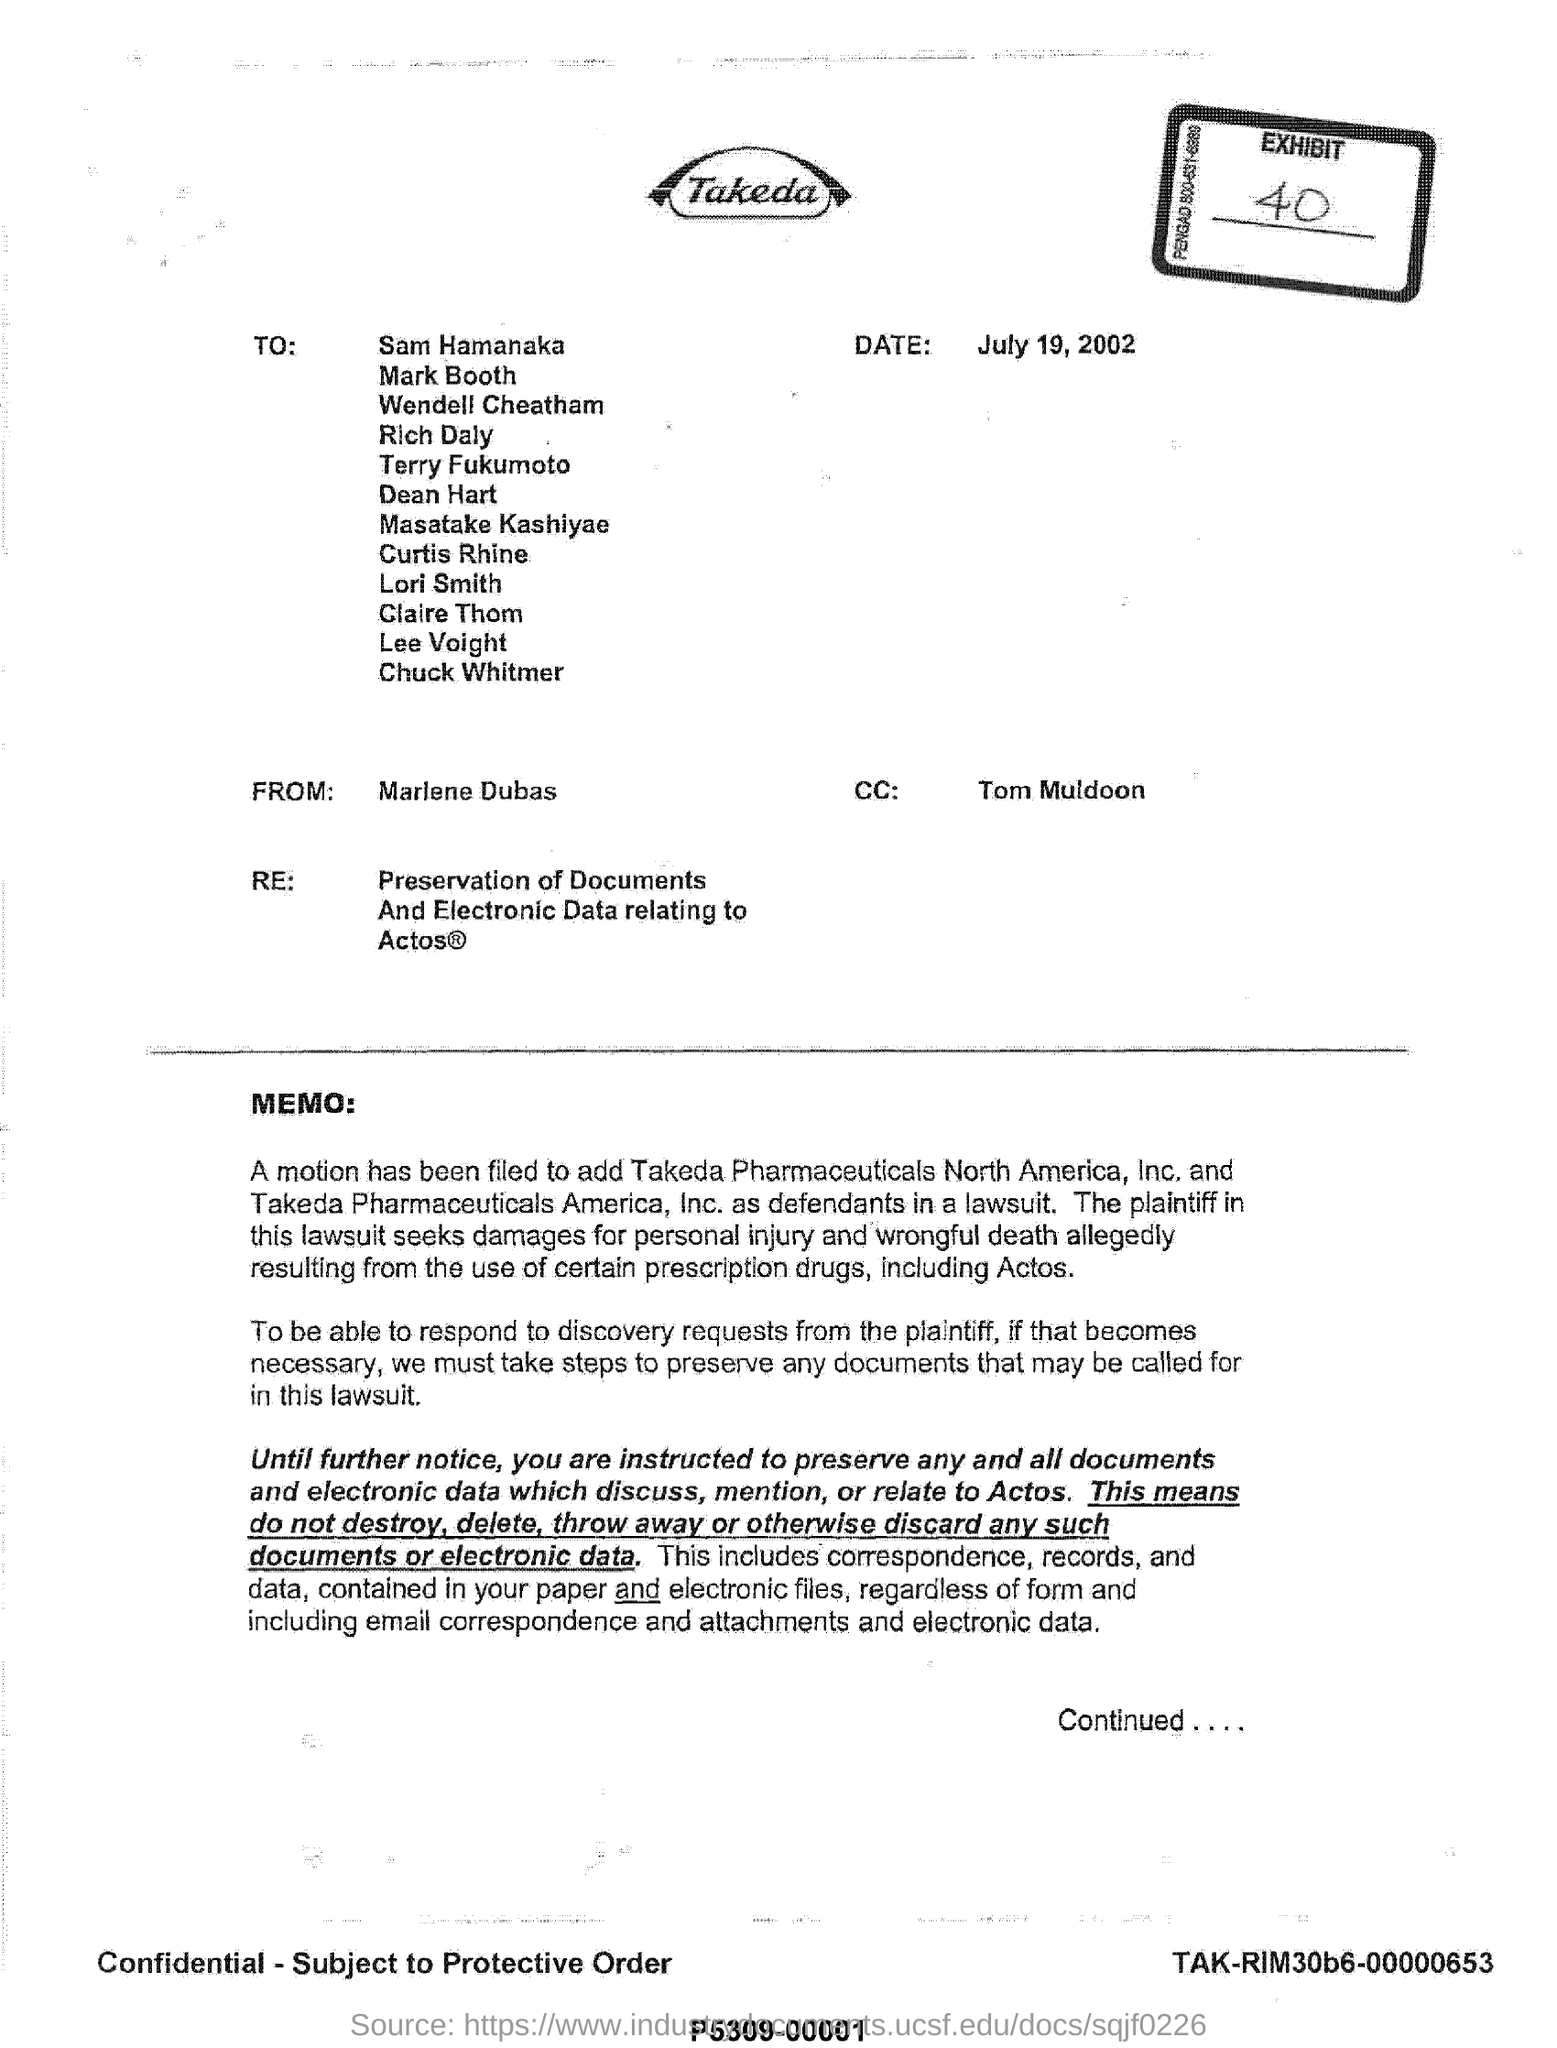Point out several critical features in this image. The recipient of the email, Tom Muldoon, is listed in the carbon copy (CC) of the email. Takeda Pharmaceuticals North America, Inc. and Takeda Pharmaceuticals America, Inc. are both defendants in a lawsuit. The letter contains the term 'RE', which refers to the preservation of documents and electronic data related to Actos. The writing of this letter is done by Marlene Dubas. 